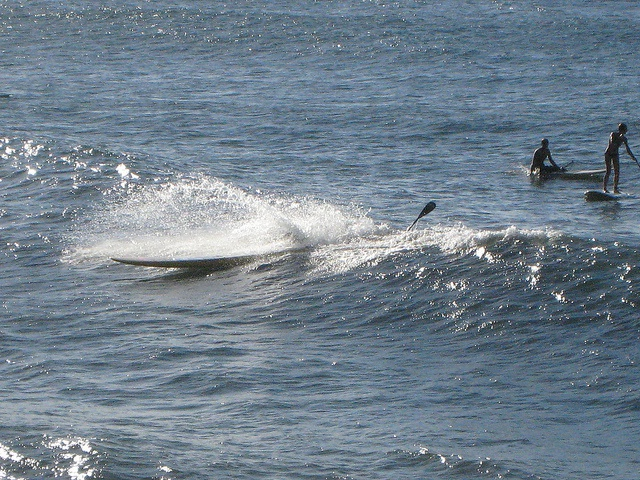Describe the objects in this image and their specific colors. I can see surfboard in gray, lightgray, darkgray, and black tones, people in gray, black, blue, and navy tones, people in gray, black, and blue tones, surfboard in gray, black, and darkgray tones, and surfboard in gray, black, and darkgray tones in this image. 